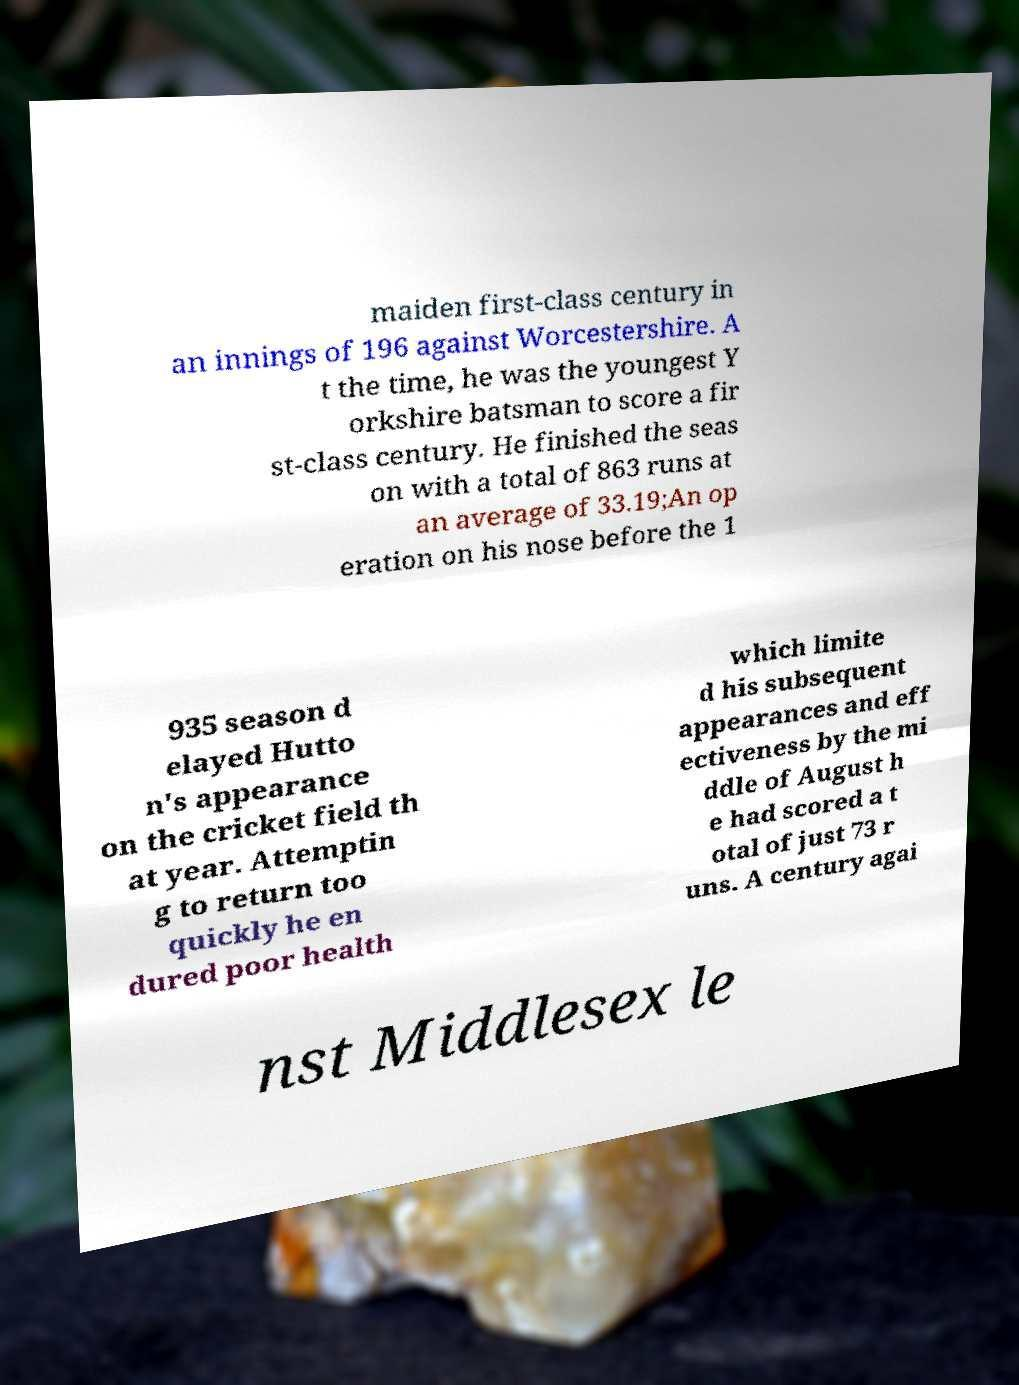Could you extract and type out the text from this image? maiden first-class century in an innings of 196 against Worcestershire. A t the time, he was the youngest Y orkshire batsman to score a fir st-class century. He finished the seas on with a total of 863 runs at an average of 33.19;An op eration on his nose before the 1 935 season d elayed Hutto n's appearance on the cricket field th at year. Attemptin g to return too quickly he en dured poor health which limite d his subsequent appearances and eff ectiveness by the mi ddle of August h e had scored a t otal of just 73 r uns. A century agai nst Middlesex le 